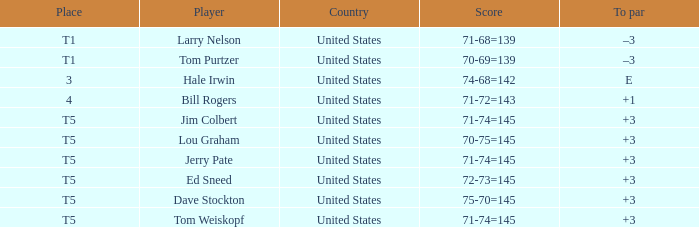What is the to par of player ed sneed, who has a t5 place? 3.0. 